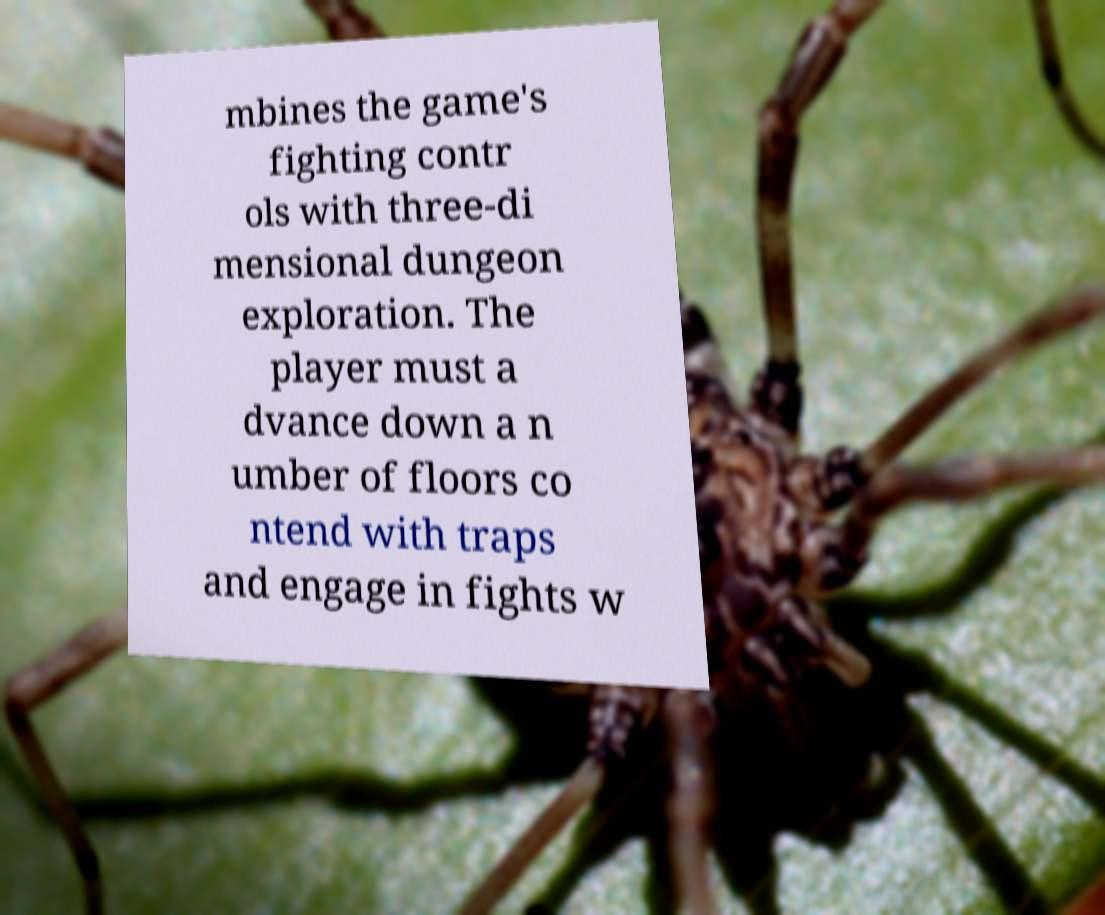There's text embedded in this image that I need extracted. Can you transcribe it verbatim? mbines the game's fighting contr ols with three-di mensional dungeon exploration. The player must a dvance down a n umber of floors co ntend with traps and engage in fights w 